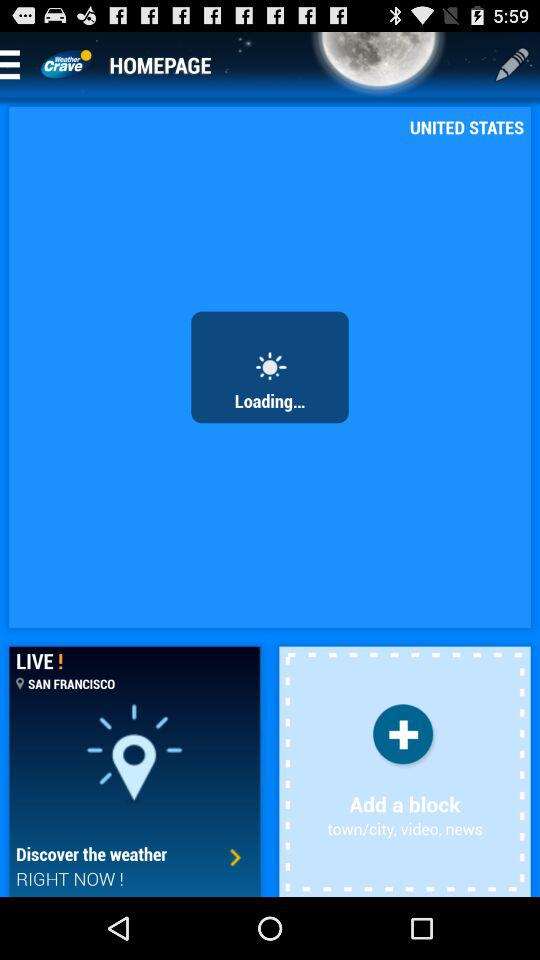What is the name of the application? The name of the application is "Weather Crave". 